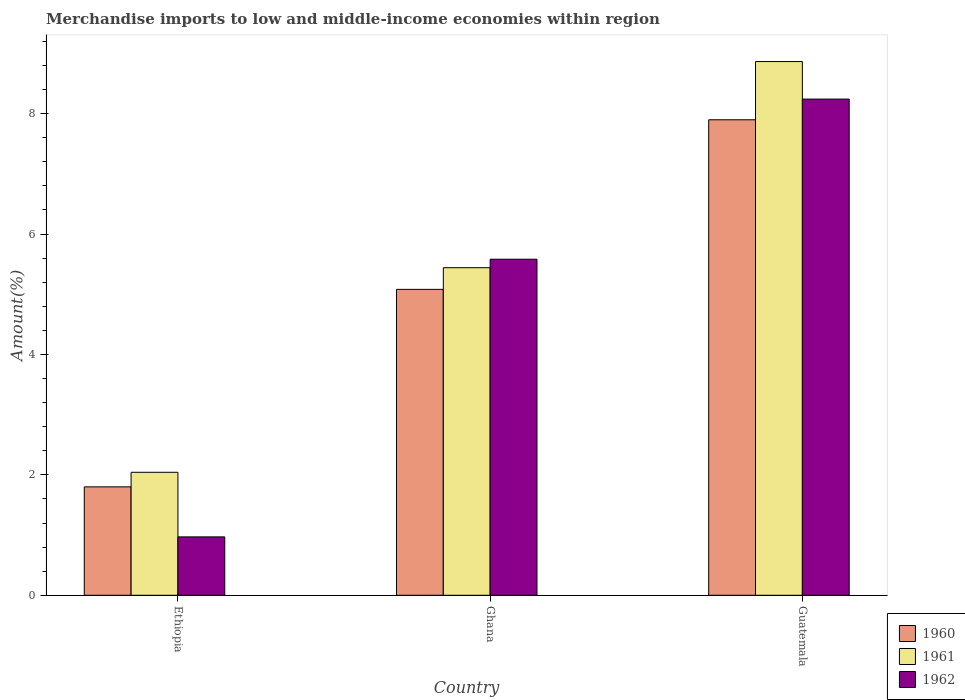How many groups of bars are there?
Give a very brief answer. 3. Are the number of bars per tick equal to the number of legend labels?
Your answer should be compact. Yes. Are the number of bars on each tick of the X-axis equal?
Keep it short and to the point. Yes. How many bars are there on the 1st tick from the left?
Your answer should be very brief. 3. How many bars are there on the 1st tick from the right?
Provide a succinct answer. 3. What is the label of the 1st group of bars from the left?
Make the answer very short. Ethiopia. In how many cases, is the number of bars for a given country not equal to the number of legend labels?
Your answer should be compact. 0. What is the percentage of amount earned from merchandise imports in 1962 in Guatemala?
Provide a succinct answer. 8.24. Across all countries, what is the maximum percentage of amount earned from merchandise imports in 1961?
Keep it short and to the point. 8.87. Across all countries, what is the minimum percentage of amount earned from merchandise imports in 1960?
Offer a terse response. 1.8. In which country was the percentage of amount earned from merchandise imports in 1961 maximum?
Provide a succinct answer. Guatemala. In which country was the percentage of amount earned from merchandise imports in 1961 minimum?
Give a very brief answer. Ethiopia. What is the total percentage of amount earned from merchandise imports in 1962 in the graph?
Provide a succinct answer. 14.79. What is the difference between the percentage of amount earned from merchandise imports in 1962 in Ethiopia and that in Guatemala?
Offer a very short reply. -7.27. What is the difference between the percentage of amount earned from merchandise imports in 1961 in Ethiopia and the percentage of amount earned from merchandise imports in 1960 in Guatemala?
Give a very brief answer. -5.86. What is the average percentage of amount earned from merchandise imports in 1962 per country?
Your response must be concise. 4.93. What is the difference between the percentage of amount earned from merchandise imports of/in 1960 and percentage of amount earned from merchandise imports of/in 1962 in Ethiopia?
Your response must be concise. 0.83. What is the ratio of the percentage of amount earned from merchandise imports in 1962 in Ethiopia to that in Ghana?
Provide a succinct answer. 0.17. Is the difference between the percentage of amount earned from merchandise imports in 1960 in Ghana and Guatemala greater than the difference between the percentage of amount earned from merchandise imports in 1962 in Ghana and Guatemala?
Your response must be concise. No. What is the difference between the highest and the second highest percentage of amount earned from merchandise imports in 1962?
Your answer should be very brief. 7.27. What is the difference between the highest and the lowest percentage of amount earned from merchandise imports in 1960?
Your answer should be compact. 6.1. Is the sum of the percentage of amount earned from merchandise imports in 1960 in Ghana and Guatemala greater than the maximum percentage of amount earned from merchandise imports in 1962 across all countries?
Your response must be concise. Yes. What does the 1st bar from the left in Guatemala represents?
Keep it short and to the point. 1960. What is the difference between two consecutive major ticks on the Y-axis?
Provide a succinct answer. 2. Does the graph contain any zero values?
Provide a succinct answer. No. How many legend labels are there?
Provide a short and direct response. 3. What is the title of the graph?
Ensure brevity in your answer.  Merchandise imports to low and middle-income economies within region. What is the label or title of the Y-axis?
Provide a short and direct response. Amount(%). What is the Amount(%) in 1960 in Ethiopia?
Make the answer very short. 1.8. What is the Amount(%) of 1961 in Ethiopia?
Your answer should be very brief. 2.04. What is the Amount(%) in 1962 in Ethiopia?
Provide a succinct answer. 0.97. What is the Amount(%) in 1960 in Ghana?
Your response must be concise. 5.08. What is the Amount(%) in 1961 in Ghana?
Ensure brevity in your answer.  5.44. What is the Amount(%) in 1962 in Ghana?
Keep it short and to the point. 5.58. What is the Amount(%) in 1960 in Guatemala?
Give a very brief answer. 7.9. What is the Amount(%) in 1961 in Guatemala?
Provide a short and direct response. 8.87. What is the Amount(%) in 1962 in Guatemala?
Keep it short and to the point. 8.24. Across all countries, what is the maximum Amount(%) of 1960?
Your answer should be compact. 7.9. Across all countries, what is the maximum Amount(%) of 1961?
Make the answer very short. 8.87. Across all countries, what is the maximum Amount(%) in 1962?
Ensure brevity in your answer.  8.24. Across all countries, what is the minimum Amount(%) in 1960?
Your answer should be compact. 1.8. Across all countries, what is the minimum Amount(%) of 1961?
Your response must be concise. 2.04. Across all countries, what is the minimum Amount(%) of 1962?
Provide a succinct answer. 0.97. What is the total Amount(%) of 1960 in the graph?
Offer a very short reply. 14.78. What is the total Amount(%) in 1961 in the graph?
Your answer should be very brief. 16.35. What is the total Amount(%) of 1962 in the graph?
Offer a terse response. 14.79. What is the difference between the Amount(%) of 1960 in Ethiopia and that in Ghana?
Offer a terse response. -3.28. What is the difference between the Amount(%) of 1961 in Ethiopia and that in Ghana?
Your answer should be very brief. -3.4. What is the difference between the Amount(%) in 1962 in Ethiopia and that in Ghana?
Provide a succinct answer. -4.61. What is the difference between the Amount(%) in 1960 in Ethiopia and that in Guatemala?
Your response must be concise. -6.1. What is the difference between the Amount(%) of 1961 in Ethiopia and that in Guatemala?
Offer a terse response. -6.82. What is the difference between the Amount(%) of 1962 in Ethiopia and that in Guatemala?
Your answer should be very brief. -7.27. What is the difference between the Amount(%) in 1960 in Ghana and that in Guatemala?
Offer a terse response. -2.82. What is the difference between the Amount(%) in 1961 in Ghana and that in Guatemala?
Keep it short and to the point. -3.42. What is the difference between the Amount(%) in 1962 in Ghana and that in Guatemala?
Your answer should be very brief. -2.66. What is the difference between the Amount(%) in 1960 in Ethiopia and the Amount(%) in 1961 in Ghana?
Give a very brief answer. -3.64. What is the difference between the Amount(%) in 1960 in Ethiopia and the Amount(%) in 1962 in Ghana?
Offer a very short reply. -3.78. What is the difference between the Amount(%) in 1961 in Ethiopia and the Amount(%) in 1962 in Ghana?
Your answer should be very brief. -3.54. What is the difference between the Amount(%) of 1960 in Ethiopia and the Amount(%) of 1961 in Guatemala?
Provide a short and direct response. -7.06. What is the difference between the Amount(%) of 1960 in Ethiopia and the Amount(%) of 1962 in Guatemala?
Offer a terse response. -6.44. What is the difference between the Amount(%) of 1961 in Ethiopia and the Amount(%) of 1962 in Guatemala?
Provide a succinct answer. -6.2. What is the difference between the Amount(%) of 1960 in Ghana and the Amount(%) of 1961 in Guatemala?
Ensure brevity in your answer.  -3.78. What is the difference between the Amount(%) in 1960 in Ghana and the Amount(%) in 1962 in Guatemala?
Ensure brevity in your answer.  -3.16. What is the difference between the Amount(%) in 1961 in Ghana and the Amount(%) in 1962 in Guatemala?
Give a very brief answer. -2.8. What is the average Amount(%) of 1960 per country?
Make the answer very short. 4.93. What is the average Amount(%) of 1961 per country?
Your response must be concise. 5.45. What is the average Amount(%) of 1962 per country?
Offer a terse response. 4.93. What is the difference between the Amount(%) in 1960 and Amount(%) in 1961 in Ethiopia?
Provide a short and direct response. -0.24. What is the difference between the Amount(%) in 1960 and Amount(%) in 1962 in Ethiopia?
Provide a short and direct response. 0.83. What is the difference between the Amount(%) of 1961 and Amount(%) of 1962 in Ethiopia?
Offer a terse response. 1.07. What is the difference between the Amount(%) of 1960 and Amount(%) of 1961 in Ghana?
Your answer should be very brief. -0.36. What is the difference between the Amount(%) of 1960 and Amount(%) of 1962 in Ghana?
Give a very brief answer. -0.5. What is the difference between the Amount(%) in 1961 and Amount(%) in 1962 in Ghana?
Offer a very short reply. -0.14. What is the difference between the Amount(%) of 1960 and Amount(%) of 1961 in Guatemala?
Provide a succinct answer. -0.97. What is the difference between the Amount(%) of 1960 and Amount(%) of 1962 in Guatemala?
Make the answer very short. -0.34. What is the difference between the Amount(%) in 1961 and Amount(%) in 1962 in Guatemala?
Your answer should be very brief. 0.62. What is the ratio of the Amount(%) in 1960 in Ethiopia to that in Ghana?
Ensure brevity in your answer.  0.35. What is the ratio of the Amount(%) in 1961 in Ethiopia to that in Ghana?
Give a very brief answer. 0.38. What is the ratio of the Amount(%) in 1962 in Ethiopia to that in Ghana?
Ensure brevity in your answer.  0.17. What is the ratio of the Amount(%) of 1960 in Ethiopia to that in Guatemala?
Give a very brief answer. 0.23. What is the ratio of the Amount(%) in 1961 in Ethiopia to that in Guatemala?
Provide a short and direct response. 0.23. What is the ratio of the Amount(%) of 1962 in Ethiopia to that in Guatemala?
Your response must be concise. 0.12. What is the ratio of the Amount(%) in 1960 in Ghana to that in Guatemala?
Your response must be concise. 0.64. What is the ratio of the Amount(%) in 1961 in Ghana to that in Guatemala?
Offer a very short reply. 0.61. What is the ratio of the Amount(%) in 1962 in Ghana to that in Guatemala?
Offer a terse response. 0.68. What is the difference between the highest and the second highest Amount(%) in 1960?
Your answer should be compact. 2.82. What is the difference between the highest and the second highest Amount(%) in 1961?
Provide a short and direct response. 3.42. What is the difference between the highest and the second highest Amount(%) in 1962?
Keep it short and to the point. 2.66. What is the difference between the highest and the lowest Amount(%) of 1960?
Ensure brevity in your answer.  6.1. What is the difference between the highest and the lowest Amount(%) of 1961?
Your response must be concise. 6.82. What is the difference between the highest and the lowest Amount(%) in 1962?
Your answer should be compact. 7.27. 